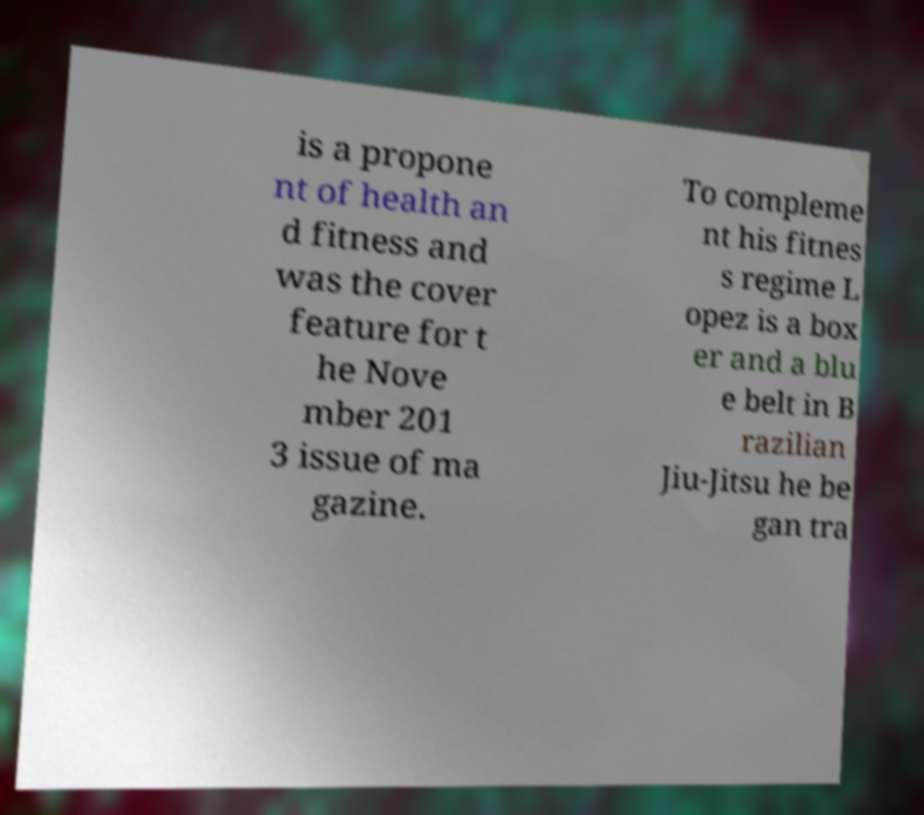Please identify and transcribe the text found in this image. is a propone nt of health an d fitness and was the cover feature for t he Nove mber 201 3 issue of ma gazine. To compleme nt his fitnes s regime L opez is a box er and a blu e belt in B razilian Jiu-Jitsu he be gan tra 